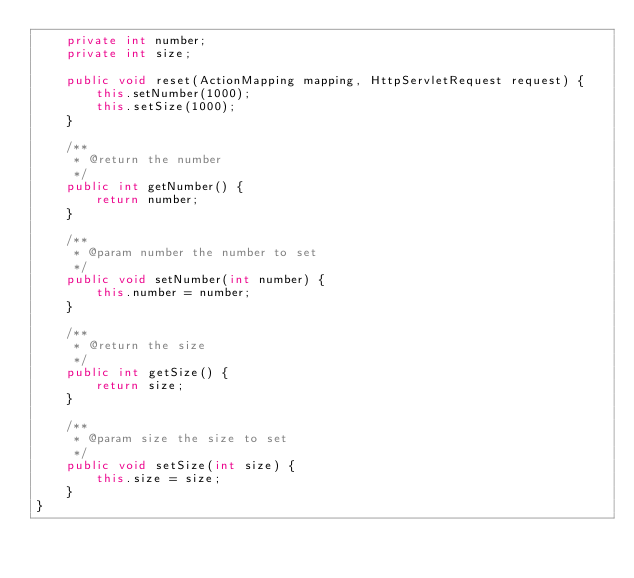<code> <loc_0><loc_0><loc_500><loc_500><_Java_>    private int number;
    private int size;

    public void reset(ActionMapping mapping, HttpServletRequest request) {
        this.setNumber(1000);
        this.setSize(1000);
    }

    /**
     * @return the number
     */
    public int getNumber() {
        return number;
    }

    /**
     * @param number the number to set
     */
    public void setNumber(int number) {
        this.number = number;
    }

    /**
     * @return the size
     */
    public int getSize() {
        return size;
    }

    /**
     * @param size the size to set
     */
    public void setSize(int size) {
        this.size = size;
    }
}
</code> 